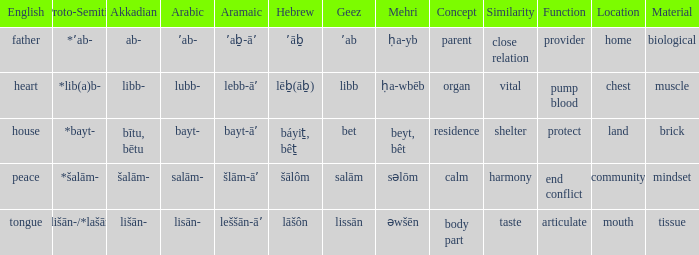In arabic, it is salām-; what is the corresponding term in proto-semitic? *šalām-. 